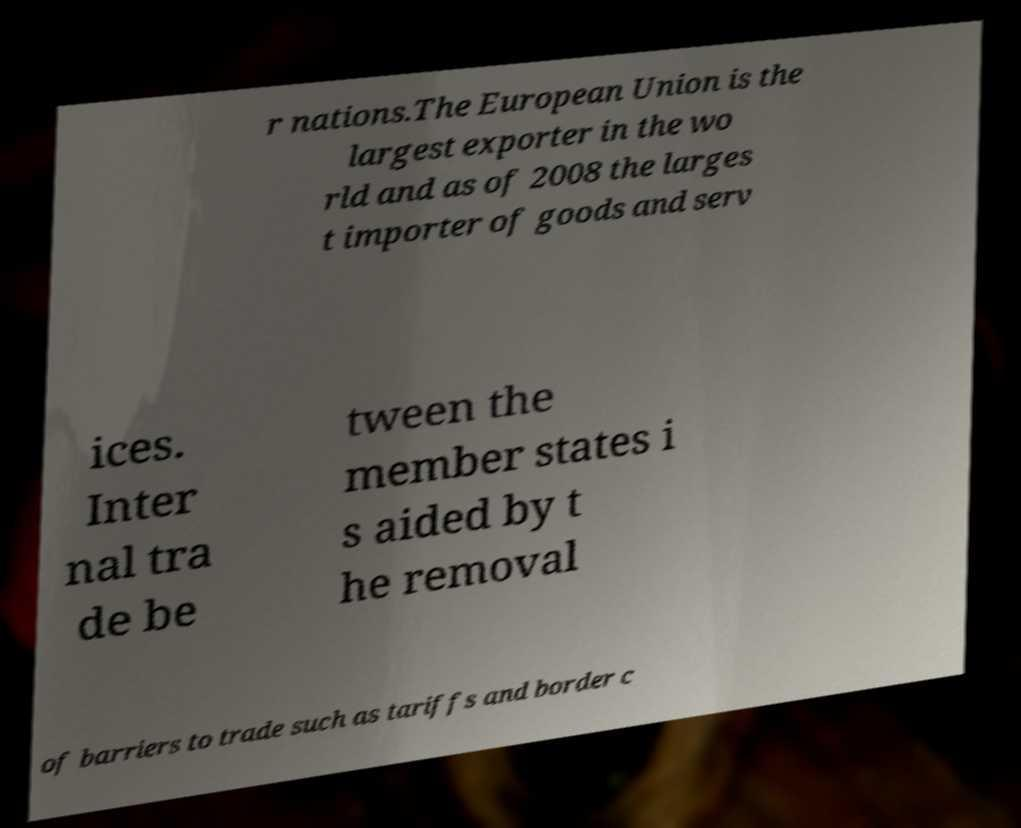Can you accurately transcribe the text from the provided image for me? r nations.The European Union is the largest exporter in the wo rld and as of 2008 the larges t importer of goods and serv ices. Inter nal tra de be tween the member states i s aided by t he removal of barriers to trade such as tariffs and border c 